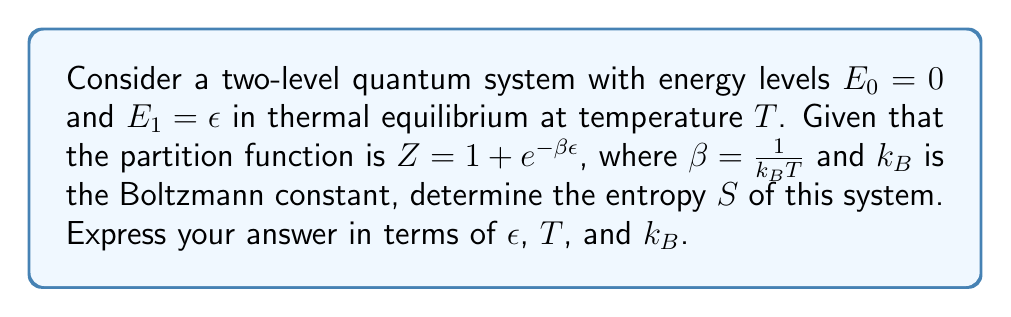Provide a solution to this math problem. To determine the entropy of this two-level quantum system, we'll follow these steps:

1) The entropy $S$ in statistical mechanics is given by:
   $$S = -k_B \sum_i p_i \ln p_i$$
   where $p_i$ is the probability of the system being in state $i$.

2) For a system in thermal equilibrium, the probabilities are given by the Boltzmann distribution:
   $$p_i = \frac{1}{Z} e^{-\beta E_i}$$

3) For our two-level system:
   $$p_0 = \frac{1}{Z}, \quad p_1 = \frac{1}{Z} e^{-\beta\epsilon}$$

4) Substituting these into the entropy formula:
   $$S = -k_B \left(\frac{1}{Z} \ln\frac{1}{Z} + \frac{1}{Z}e^{-\beta\epsilon} \ln\frac{1}{Z}e^{-\beta\epsilon}\right)$$

5) Simplify:
   $$S = -k_B \left(\frac{1}{Z} \ln\frac{1}{Z} + \frac{1}{Z}e^{-\beta\epsilon} \ln\frac{1}{Z} - \frac{1}{Z}e^{-\beta\epsilon} \beta\epsilon\right)$$

6) Factor out common terms:
   $$S = k_B \left(\ln Z - \frac{1}{Z}e^{-\beta\epsilon} \beta\epsilon\right)$$

7) Recall that $Z = 1 + e^{-\beta\epsilon}$, so $\frac{1}{Z}e^{-\beta\epsilon} = \frac{e^{-\beta\epsilon}}{1 + e^{-\beta\epsilon}}$

8) Substitute this back:
   $$S = k_B \left(\ln(1 + e^{-\beta\epsilon}) - \frac{e^{-\beta\epsilon}}{1 + e^{-\beta\epsilon}} \beta\epsilon\right)$$

9) Recognize that $\beta = \frac{1}{k_B T}$:
   $$S = k_B \ln(1 + e^{-\epsilon/k_B T}) + \frac{\epsilon}{T} \frac{e^{-\epsilon/k_B T}}{1 + e^{-\epsilon/k_B T}}$$

This is the final expression for the entropy of the two-level quantum system.
Answer: $S = k_B \ln(1 + e^{-\epsilon/k_B T}) + \frac{\epsilon}{T} \frac{e^{-\epsilon/k_B T}}{1 + e^{-\epsilon/k_B T}}$ 